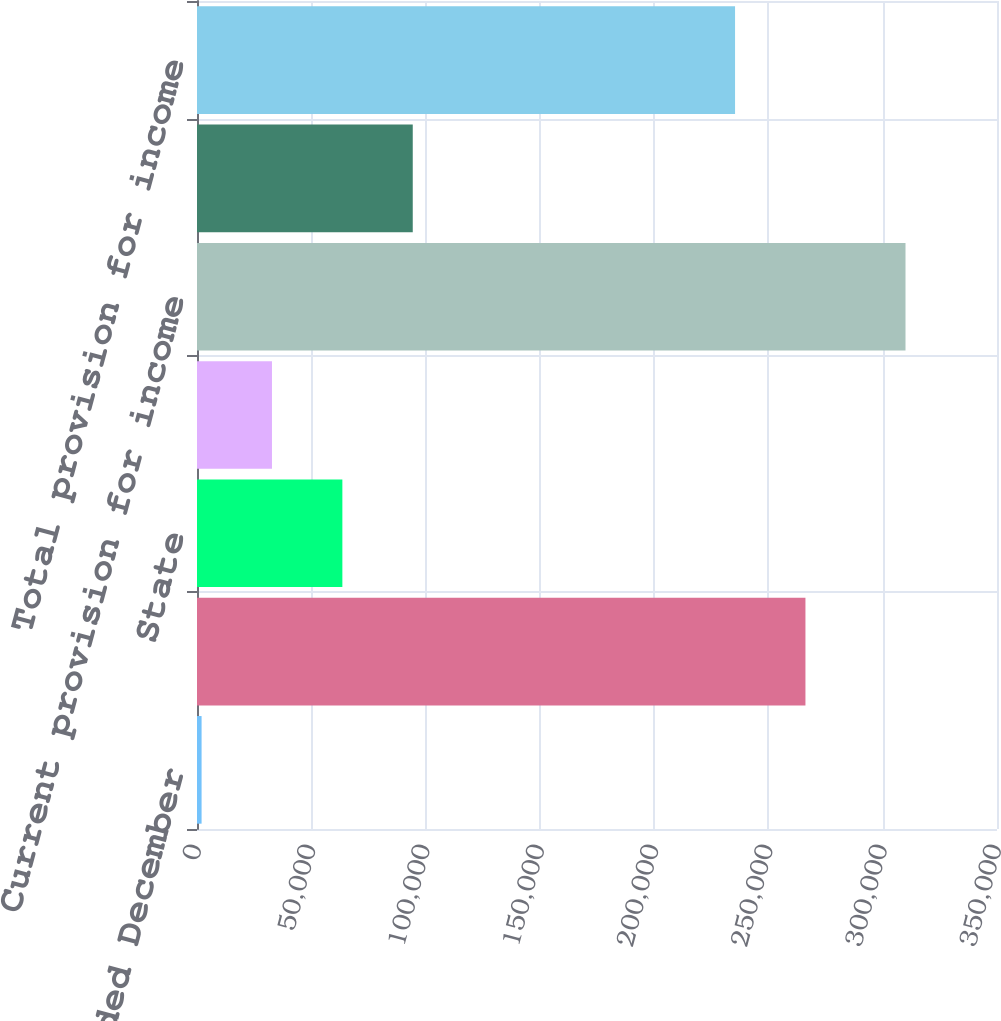Convert chart. <chart><loc_0><loc_0><loc_500><loc_500><bar_chart><fcel>For the years ended December<fcel>Federal<fcel>State<fcel>Foreign<fcel>Current provision for income<fcel>Deferred income tax provision<fcel>Total provision for income<nl><fcel>2004<fcel>266196<fcel>63597<fcel>32800.5<fcel>309969<fcel>94393.5<fcel>235399<nl></chart> 